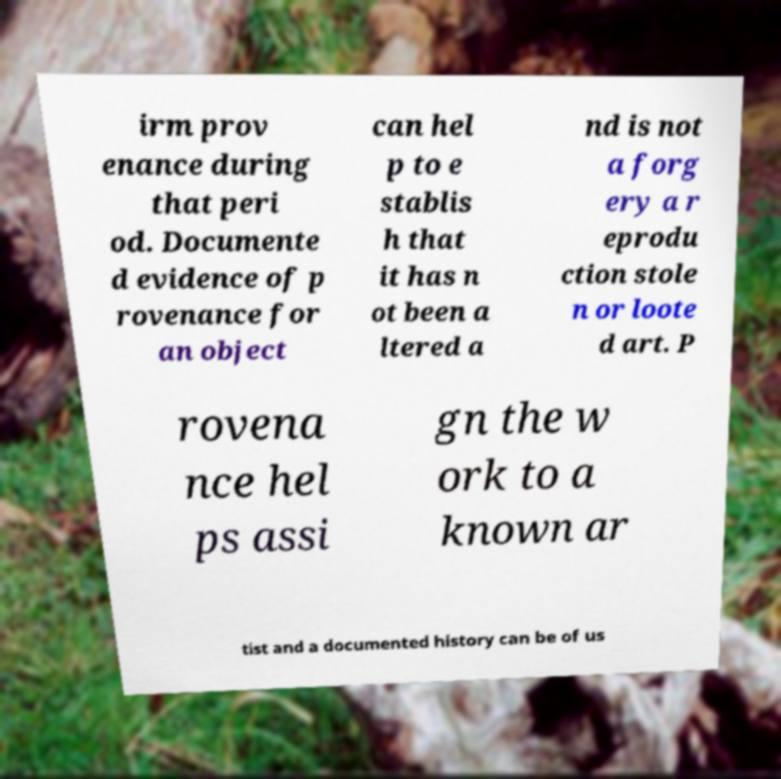Could you assist in decoding the text presented in this image and type it out clearly? irm prov enance during that peri od. Documente d evidence of p rovenance for an object can hel p to e stablis h that it has n ot been a ltered a nd is not a forg ery a r eprodu ction stole n or loote d art. P rovena nce hel ps assi gn the w ork to a known ar tist and a documented history can be of us 